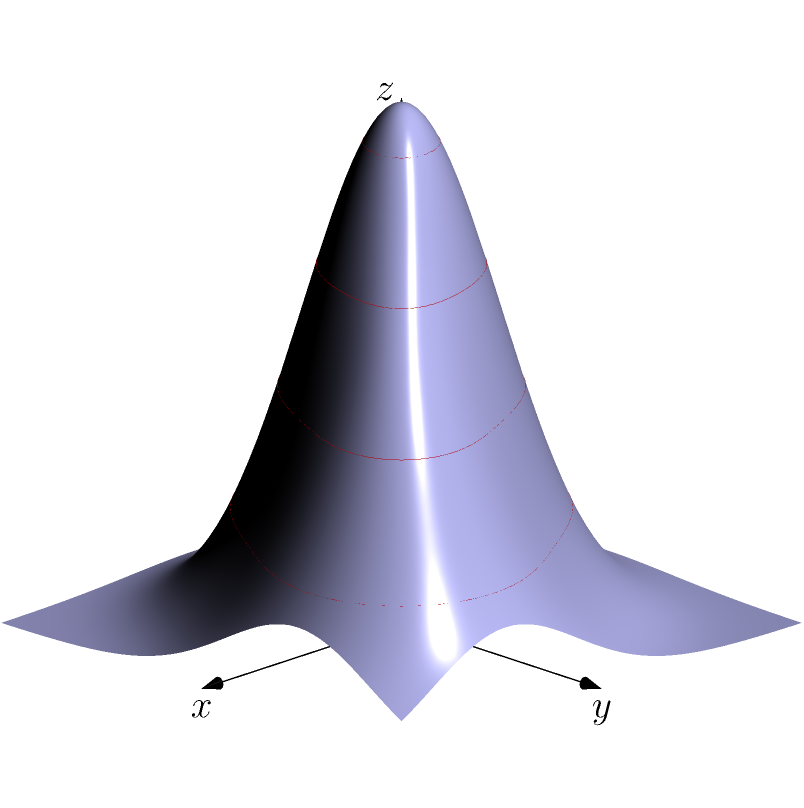Given the contour plot and its corresponding 3D surface representation, what can be inferred about the relationship between the contour lines and the shape of the surface? How would you interpret the areas where the contour lines are closer together versus farther apart? To interpret the relationship between the contour lines and the 3D surface:

1. Contour lines represent points of equal height (z-value) on the surface.

2. Closer contour lines indicate steeper slopes:
   - Where contour lines are tightly packed, the surface has a steep gradient.
   - This is visible in the 3D plot as areas with rapid changes in height.

3. Wider-spaced contour lines indicate gentler slopes:
   - Areas with more spread-out contour lines correspond to flatter regions on the surface.
   - In the 3D plot, these appear as more gradually changing areas.

4. Closed contour lines often indicate peaks or valleys:
   - In this plot, we see two sets of closed contours, suggesting two local maxima.
   - The 3D surface confirms this, showing two distinct peaks.

5. The highest contour values correspond to the peaks in the 3D surface:
   - The innermost closed contours represent the highest points on the surface.

6. The shape of the contours reflects the overall shape of the surface:
   - Circular contours indicate a roughly symmetrical surface feature.
   - Here, the circular contours correspond to the rounded peaks in the 3D surface.

7. The spacing between contour lines indicates the rate of change:
   - Consistent spacing suggests a uniform slope.
   - Varying spacing indicates changing slopes, as seen in the transitions between the peaks and the surrounding area.

In statistical modeling, this visualization helps in understanding the distribution and relationships between variables, identifying areas of rapid change or stability in the data.
Answer: Closer contour lines indicate steeper slopes; wider spacing indicates gentler slopes. Closed contours often represent peaks or valleys, with contour shapes reflecting surface features. 